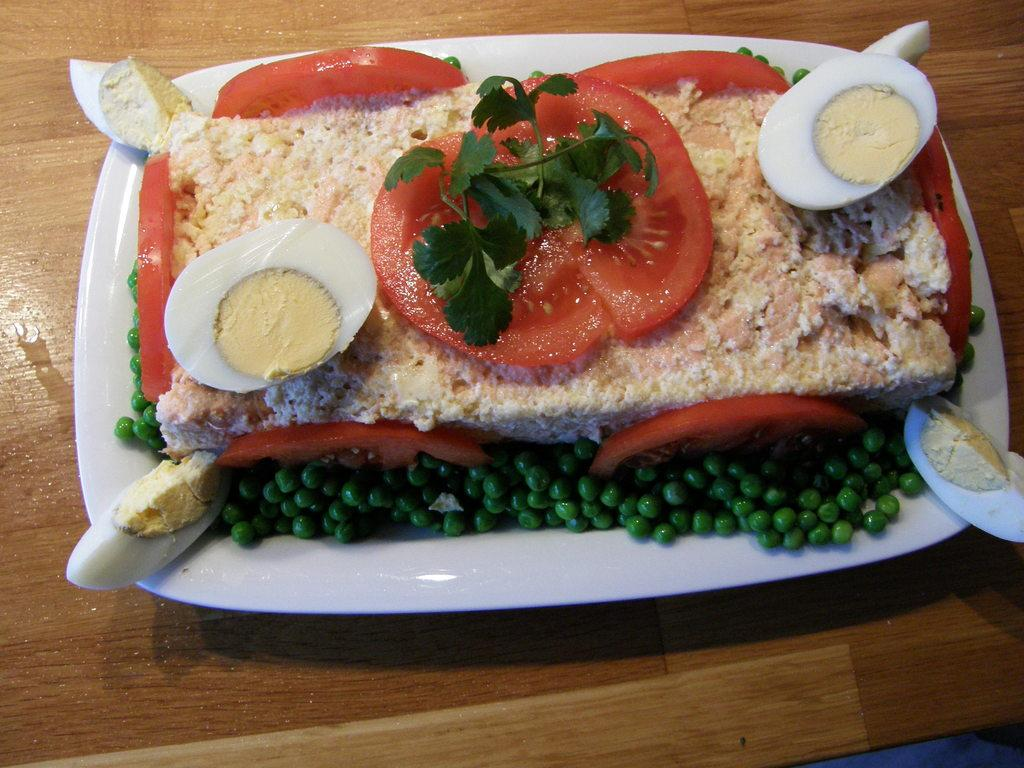What object is present on the table in the image? There is a plate on the table in the image. What is the purpose of the plate in the image? The plate is used to hold food. What type of food can be seen on the plate? The facts do not specify the type of food on the plate. What type of pain is the person experiencing while looking at the plate in the image? There is no person present in the image, and therefore no indication of any pain being experienced. 